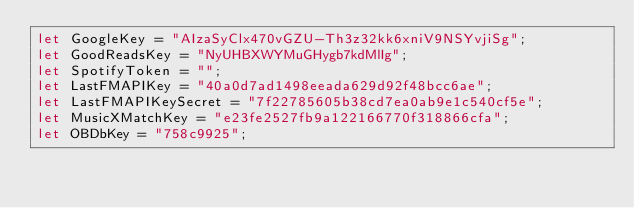Convert code to text. <code><loc_0><loc_0><loc_500><loc_500><_JavaScript_>let GoogleKey = "AIzaSyClx470vGZU-Th3z32kk6xniV9NSYvjiSg";
let GoodReadsKey = "NyUHBXWYMuGHygb7kdMlIg";
let SpotifyToken = "";
let LastFMAPIKey = "40a0d7ad1498eeada629d92f48bcc6ae";
let LastFMAPIKeySecret = "7f22785605b38cd7ea0ab9e1c540cf5e";
let MusicXMatchKey = "e23fe2527fb9a122166770f318866cfa";
let OBDbKey = "758c9925";</code> 